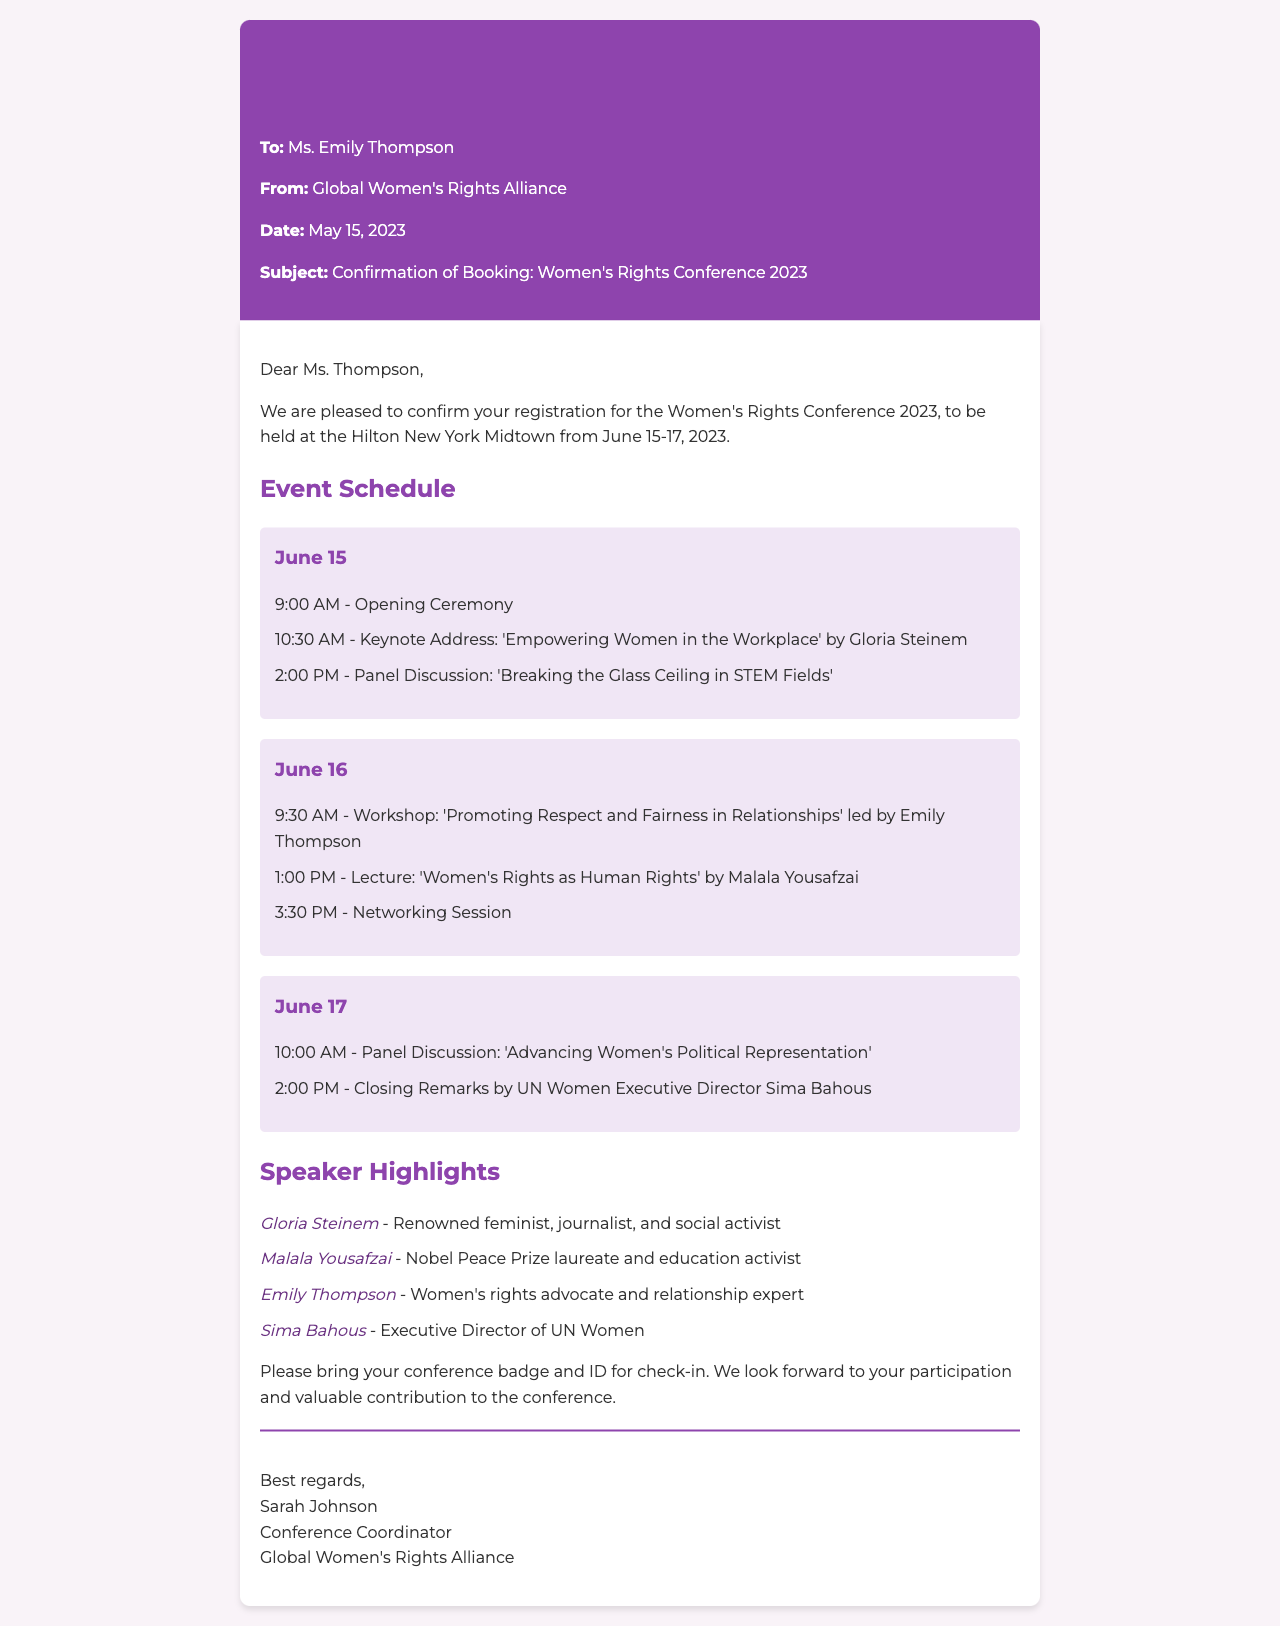What are the dates of the conference? The document specifies that the Women's Rights Conference 2023 will be held from June 15-17, 2023.
Answer: June 15-17, 2023 Who is the keynote speaker on June 15? The keynote address on June 15 is delivered by Gloria Steinem, as mentioned in the event schedule.
Answer: Gloria Steinem What workshop is being led by Emily Thompson? The schedule indicates that Emily Thompson will lead the workshop titled "Promoting Respect and Fairness in Relationships".
Answer: Promoting Respect and Fairness in Relationships Which organization's executive director will give closing remarks? The document states that the closing remarks will be given by Sima Bahous, who is the Executive Director of UN Women.
Answer: UN Women How many days will the conference last? The document outlines that the conference will take place over three days.
Answer: Three days What is the location of the conference? The document confirms that the Women's Rights Conference 2023 will be held at the Hilton New York Midtown.
Answer: Hilton New York Midtown What is required for check-in at the conference? Attendees are instructed to bring their conference badge and ID for check-in as indicated in the document.
Answer: Conference badge and ID Which speaker is a Nobel Peace Prize laureate? The document notes that Malala Yousafzai is a Nobel Peace Prize laureate and education activist.
Answer: Malala Yousafzai What color is the fax header? The styling of the fax header is indicated to have a background color of dark purple (#8e44ad).
Answer: Dark purple 